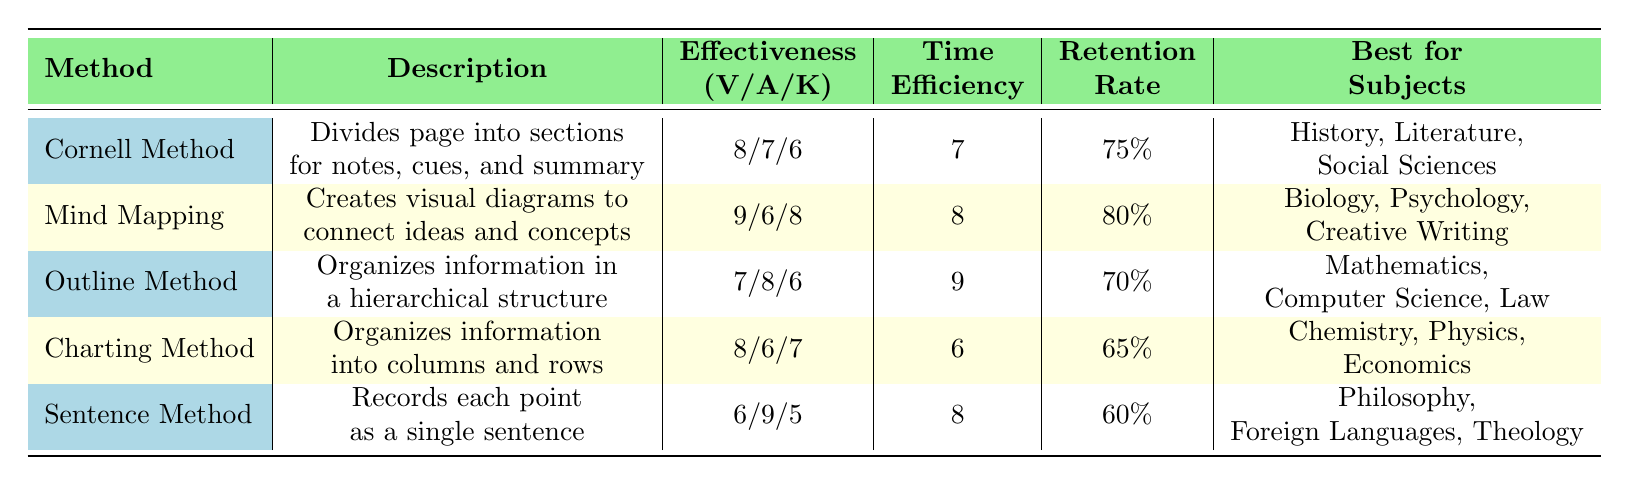What is the retention rate for the Mind Mapping method? The retention rate for the Mind Mapping method is listed in the table. Referring to the table, it is clearly stated as 80%.
Answer: 80% Which note-taking method is the best for auditory learners? To find the best method for auditory learners, we compare the effectiveness scores for the auditory learning style across all methods. The Sentence Method has the highest score of 9.
Answer: Sentence Method What are the best subjects for using the Cornell Method? The table specifies the best subjects for the Cornell Method. By checking that row, the best subjects listed are History, Literature, and Social Sciences.
Answer: History, Literature, Social Sciences What is the average time efficiency rating across all methods? To find the average time efficiency, we sum the time efficiency ratings: (7 + 8 + 9 + 6 + 8) = 38. Then, we divide this sum by the number of methods (5). So, the average is 38/5 = 7.6.
Answer: 7.6 Is the retention rate for the Charting Method greater than 65%? The retention rate for the Charting Method is explicitly listed as 65%. Therefore, checking if it is greater than 65% shows that it is not.
Answer: No Which method is more time-efficient, the Outline Method or the Mind Mapping method? The time efficiency rating for the Outline Method is 9 and for the Mind Mapping method, it is 8. Comparing these values shows that the Outline Method is more time-efficient.
Answer: Outline Method What is the effectiveness score for the visual learning style of the Charting Method? Upon looking at the Charting Method's effectiveness scores, the score for the visual learning style is specified as 8.
Answer: 8 If we consider the retention rates, which method has the lowest retention rate? By examining the retention rates for all methods, the Sentence Method has the lowest rate at 60%.
Answer: Sentence Method In terms of effectiveness for kinesthetic learners, which method is least effective? For kinesthetic learners, the effectiveness scores are compared: Cornell Method (6), Mind Mapping (8), Outline Method (6), Charting Method (7), and Sentence Method (5). The Sentence Method has the lowest score of 5.
Answer: Sentence Method 